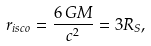Convert formula to latex. <formula><loc_0><loc_0><loc_500><loc_500>r _ { i s c o } = { \frac { 6 \, G M } { c ^ { 2 } } } = 3 R _ { S } ,</formula> 